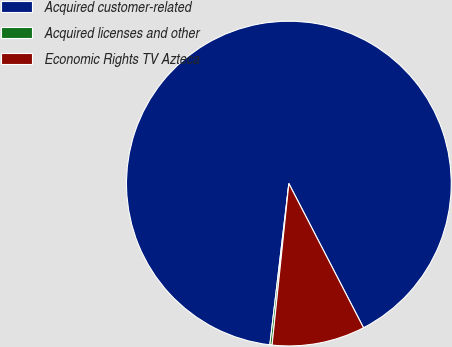Convert chart to OTSL. <chart><loc_0><loc_0><loc_500><loc_500><pie_chart><fcel>Acquired customer-related<fcel>Acquired licenses and other<fcel>Economic Rights TV Azteca<nl><fcel>90.52%<fcel>0.22%<fcel>9.25%<nl></chart> 